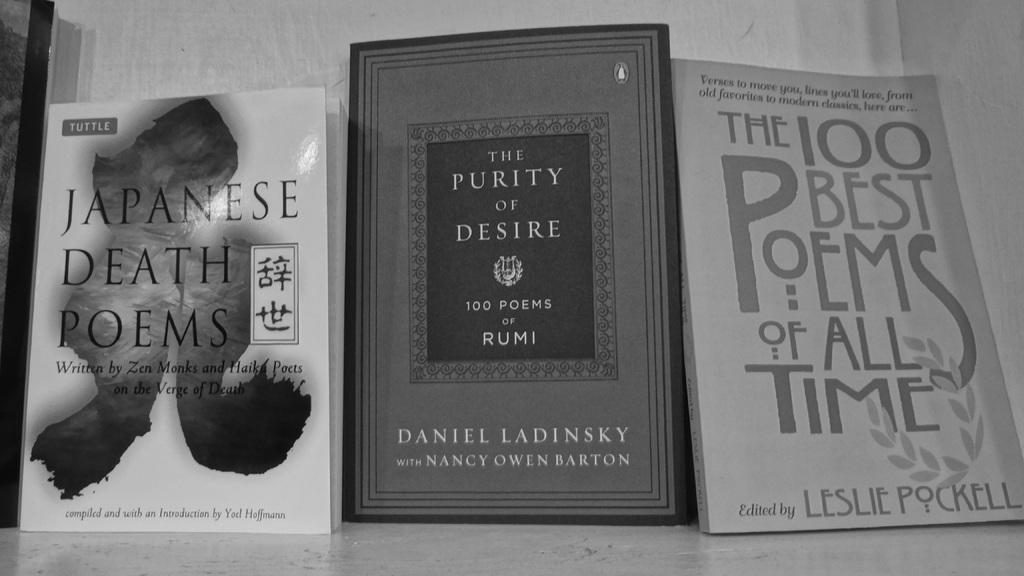What is the title of the book on the right?
Your answer should be very brief. The 100 best poems of all time. 